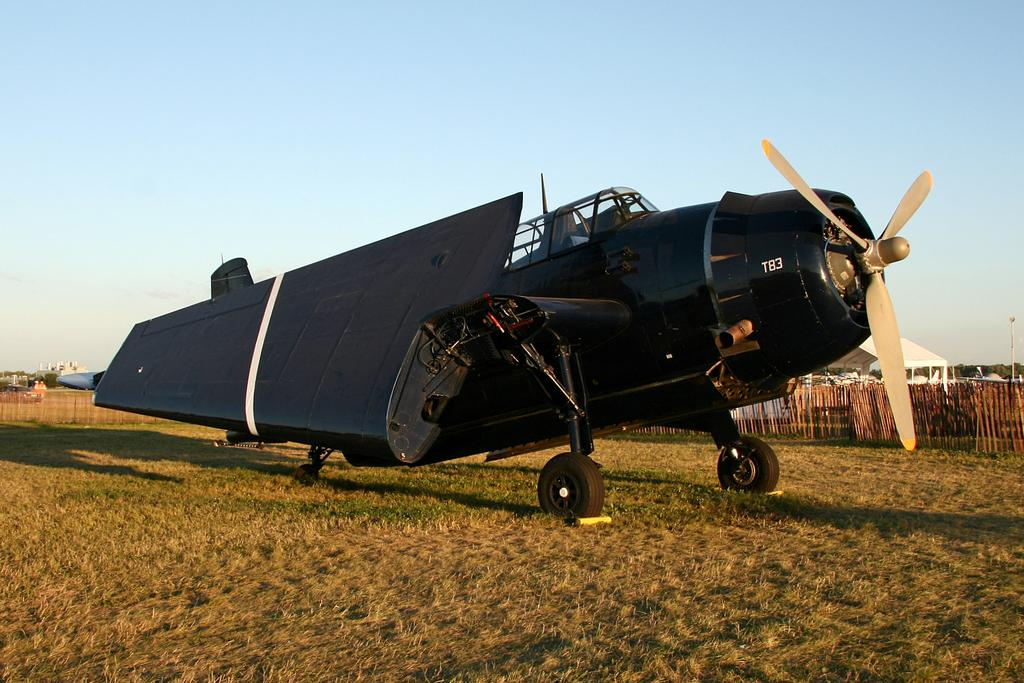<image>
Write a terse but informative summary of the picture. A black plane with folded wings is parked in grass and says T83 on the front. 